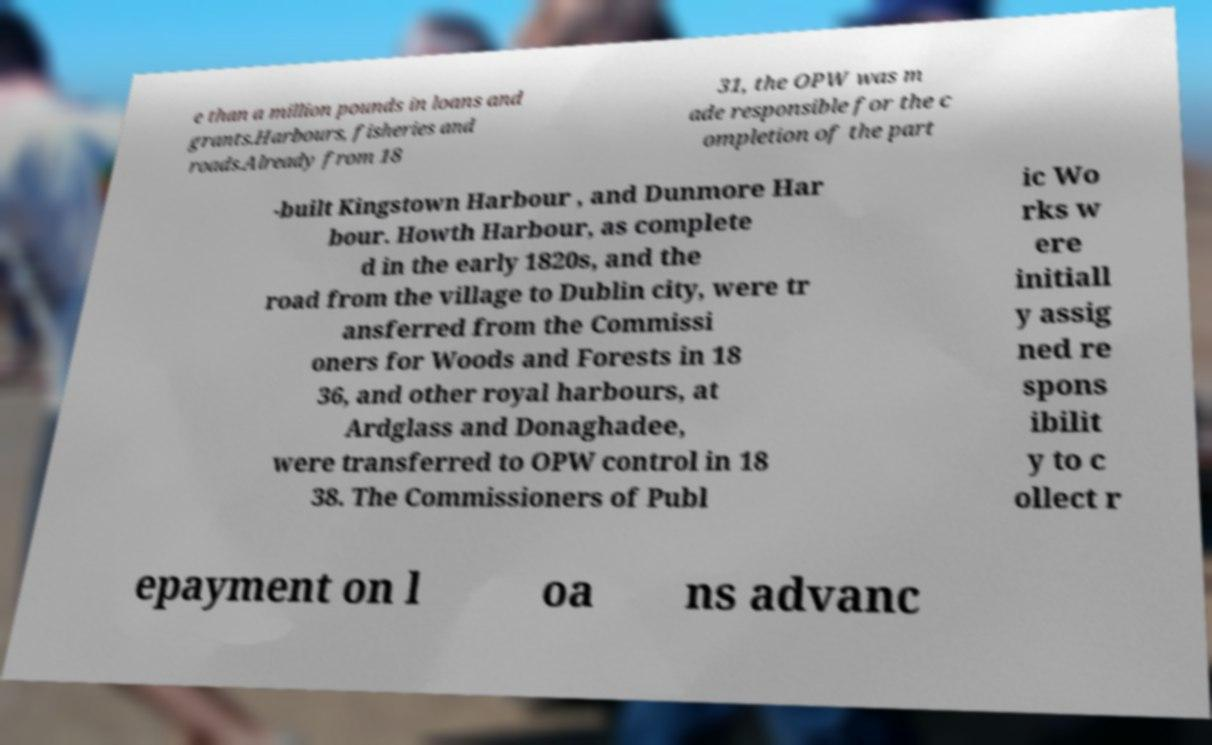I need the written content from this picture converted into text. Can you do that? e than a million pounds in loans and grants.Harbours, fisheries and roads.Already from 18 31, the OPW was m ade responsible for the c ompletion of the part -built Kingstown Harbour , and Dunmore Har bour. Howth Harbour, as complete d in the early 1820s, and the road from the village to Dublin city, were tr ansferred from the Commissi oners for Woods and Forests in 18 36, and other royal harbours, at Ardglass and Donaghadee, were transferred to OPW control in 18 38. The Commissioners of Publ ic Wo rks w ere initiall y assig ned re spons ibilit y to c ollect r epayment on l oa ns advanc 